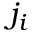<formula> <loc_0><loc_0><loc_500><loc_500>j _ { i }</formula> 